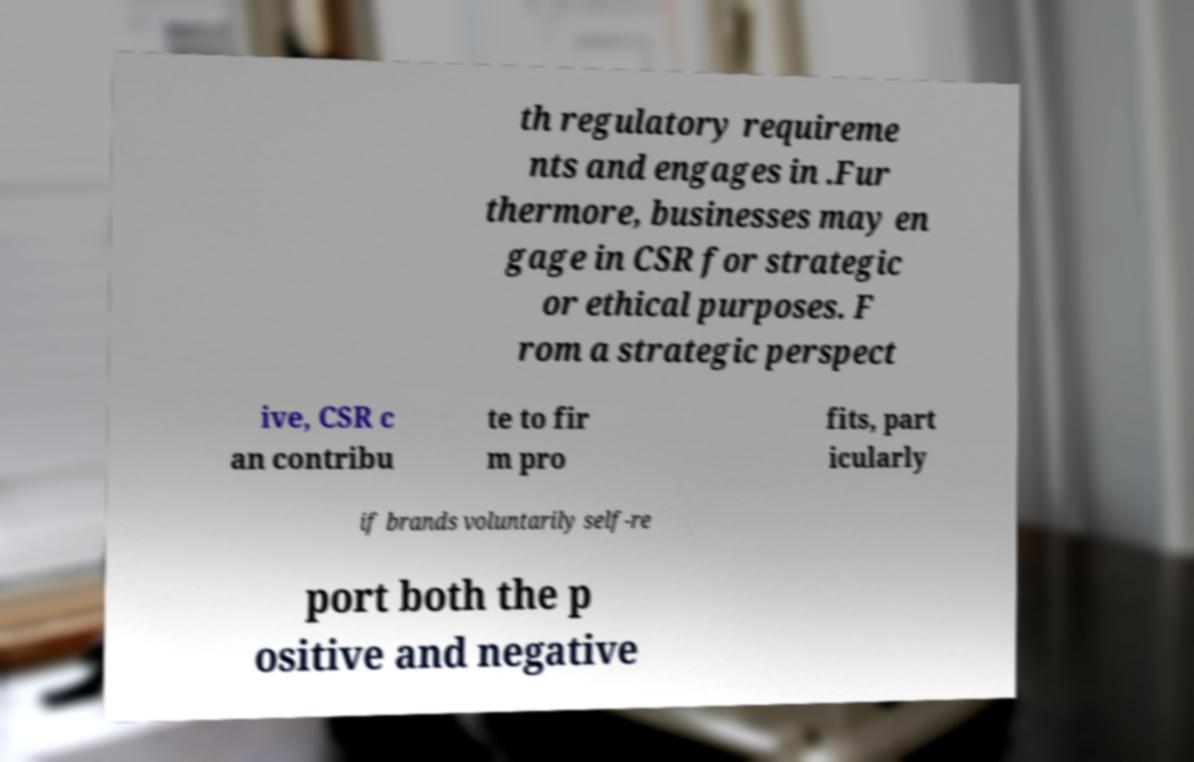Can you accurately transcribe the text from the provided image for me? th regulatory requireme nts and engages in .Fur thermore, businesses may en gage in CSR for strategic or ethical purposes. F rom a strategic perspect ive, CSR c an contribu te to fir m pro fits, part icularly if brands voluntarily self-re port both the p ositive and negative 